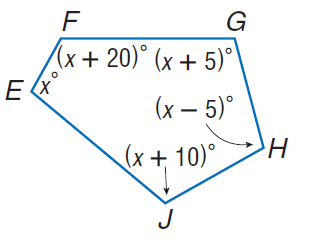Answer the mathemtical geometry problem and directly provide the correct option letter.
Question: Find m \angle J.
Choices: A: 102 B: 107 C: 112 D: 117 C 